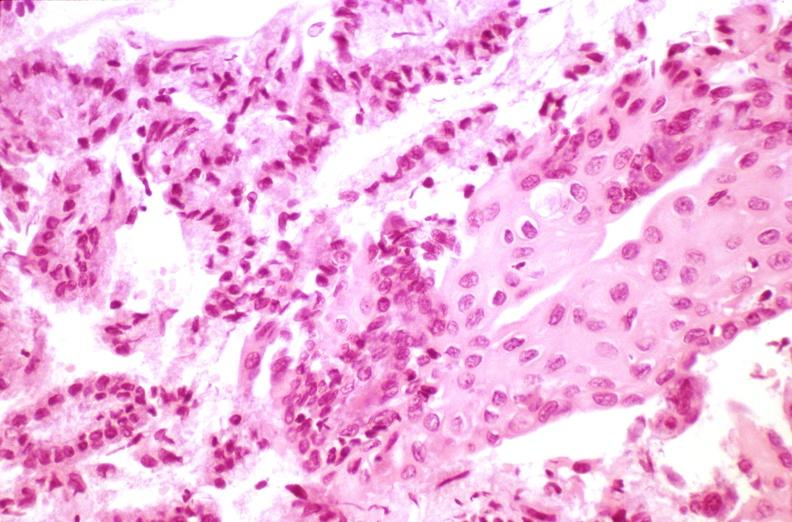s female reproductive present?
Answer the question using a single word or phrase. Yes 